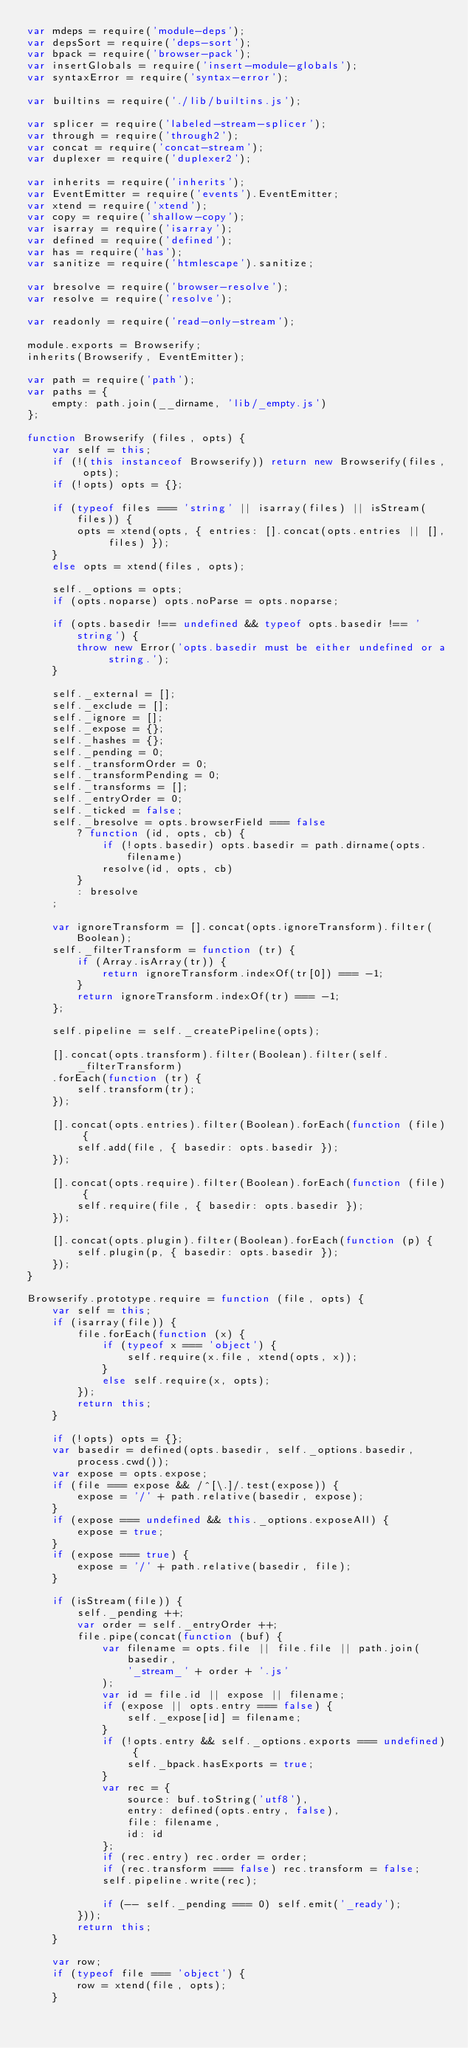Convert code to text. <code><loc_0><loc_0><loc_500><loc_500><_JavaScript_>var mdeps = require('module-deps');
var depsSort = require('deps-sort');
var bpack = require('browser-pack');
var insertGlobals = require('insert-module-globals');
var syntaxError = require('syntax-error');

var builtins = require('./lib/builtins.js');

var splicer = require('labeled-stream-splicer');
var through = require('through2');
var concat = require('concat-stream');
var duplexer = require('duplexer2');

var inherits = require('inherits');
var EventEmitter = require('events').EventEmitter;
var xtend = require('xtend');
var copy = require('shallow-copy');
var isarray = require('isarray');
var defined = require('defined');
var has = require('has');
var sanitize = require('htmlescape').sanitize;

var bresolve = require('browser-resolve');
var resolve = require('resolve');

var readonly = require('read-only-stream');

module.exports = Browserify;
inherits(Browserify, EventEmitter);

var path = require('path');
var paths = {
    empty: path.join(__dirname, 'lib/_empty.js')
};

function Browserify (files, opts) {
    var self = this;
    if (!(this instanceof Browserify)) return new Browserify(files, opts);
    if (!opts) opts = {};
    
    if (typeof files === 'string' || isarray(files) || isStream(files)) {
        opts = xtend(opts, { entries: [].concat(opts.entries || [], files) });
    }
    else opts = xtend(files, opts);
    
    self._options = opts;
    if (opts.noparse) opts.noParse = opts.noparse;
    
    if (opts.basedir !== undefined && typeof opts.basedir !== 'string') {
        throw new Error('opts.basedir must be either undefined or a string.');
    }
    
    self._external = [];
    self._exclude = [];
    self._ignore = [];
    self._expose = {};
    self._hashes = {};
    self._pending = 0;
    self._transformOrder = 0;
    self._transformPending = 0;
    self._transforms = [];
    self._entryOrder = 0;
    self._ticked = false;
    self._bresolve = opts.browserField === false
        ? function (id, opts, cb) {
            if (!opts.basedir) opts.basedir = path.dirname(opts.filename)
            resolve(id, opts, cb)
        }
        : bresolve
    ;

    var ignoreTransform = [].concat(opts.ignoreTransform).filter(Boolean);
    self._filterTransform = function (tr) {
        if (Array.isArray(tr)) {
            return ignoreTransform.indexOf(tr[0]) === -1;
        }
        return ignoreTransform.indexOf(tr) === -1;
    };

    self.pipeline = self._createPipeline(opts);
    
    [].concat(opts.transform).filter(Boolean).filter(self._filterTransform)
    .forEach(function (tr) {
        self.transform(tr);
    });
    
    [].concat(opts.entries).filter(Boolean).forEach(function (file) {
        self.add(file, { basedir: opts.basedir });
    });
    
    [].concat(opts.require).filter(Boolean).forEach(function (file) {
        self.require(file, { basedir: opts.basedir });
    });
    
    [].concat(opts.plugin).filter(Boolean).forEach(function (p) {
        self.plugin(p, { basedir: opts.basedir });
    });
}

Browserify.prototype.require = function (file, opts) {
    var self = this;
    if (isarray(file)) {
        file.forEach(function (x) {
            if (typeof x === 'object') {
                self.require(x.file, xtend(opts, x));
            }
            else self.require(x, opts);
        });
        return this;
    }
    
    if (!opts) opts = {};
    var basedir = defined(opts.basedir, self._options.basedir, process.cwd());
    var expose = opts.expose;
    if (file === expose && /^[\.]/.test(expose)) {
        expose = '/' + path.relative(basedir, expose);
    }
    if (expose === undefined && this._options.exposeAll) {
        expose = true;
    }
    if (expose === true) {
        expose = '/' + path.relative(basedir, file);
    }
    
    if (isStream(file)) {
        self._pending ++;
        var order = self._entryOrder ++;
        file.pipe(concat(function (buf) {
            var filename = opts.file || file.file || path.join(
                basedir,
                '_stream_' + order + '.js'
            );
            var id = file.id || expose || filename;
            if (expose || opts.entry === false) {
                self._expose[id] = filename;
            }
            if (!opts.entry && self._options.exports === undefined) {
                self._bpack.hasExports = true;
            }
            var rec = {
                source: buf.toString('utf8'),
                entry: defined(opts.entry, false),
                file: filename,
                id: id
            };
            if (rec.entry) rec.order = order;
            if (rec.transform === false) rec.transform = false;
            self.pipeline.write(rec);
            
            if (-- self._pending === 0) self.emit('_ready');
        }));
        return this;
    }
    
    var row;
    if (typeof file === 'object') {
        row = xtend(file, opts);
    }</code> 